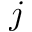<formula> <loc_0><loc_0><loc_500><loc_500>j</formula> 